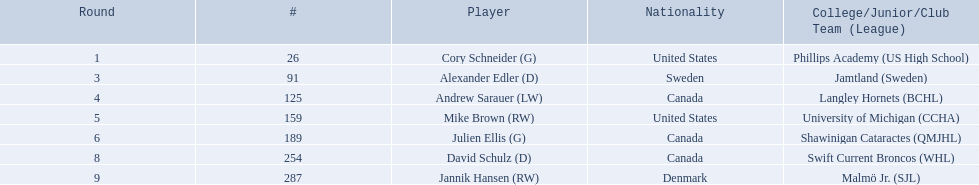What are the nationalities of the players? United States, Sweden, Canada, United States, Canada, Canada, Denmark. Of the players, which one lists his nationality as denmark? Jannik Hansen (RW). Parse the table in full. {'header': ['Round', '#', 'Player', 'Nationality', 'College/Junior/Club Team (League)'], 'rows': [['1', '26', 'Cory Schneider (G)', 'United States', 'Phillips Academy (US High School)'], ['3', '91', 'Alexander Edler (D)', 'Sweden', 'Jamtland (Sweden)'], ['4', '125', 'Andrew Sarauer (LW)', 'Canada', 'Langley Hornets (BCHL)'], ['5', '159', 'Mike Brown (RW)', 'United States', 'University of Michigan (CCHA)'], ['6', '189', 'Julien Ellis (G)', 'Canada', 'Shawinigan Cataractes (QMJHL)'], ['8', '254', 'David Schulz (D)', 'Canada', 'Swift Current Broncos (WHL)'], ['9', '287', 'Jannik Hansen (RW)', 'Denmark', 'Malmö Jr. (SJL)']]} Who are all the players? Cory Schneider (G), Alexander Edler (D), Andrew Sarauer (LW), Mike Brown (RW), Julien Ellis (G), David Schulz (D), Jannik Hansen (RW). What is the nationality of each player? United States, Sweden, Canada, United States, Canada, Canada, Denmark. Where did they attend school? Phillips Academy (US High School), Jamtland (Sweden), Langley Hornets (BCHL), University of Michigan (CCHA), Shawinigan Cataractes (QMJHL), Swift Current Broncos (WHL), Malmö Jr. (SJL). Which player attended langley hornets? Andrew Sarauer (LW). 